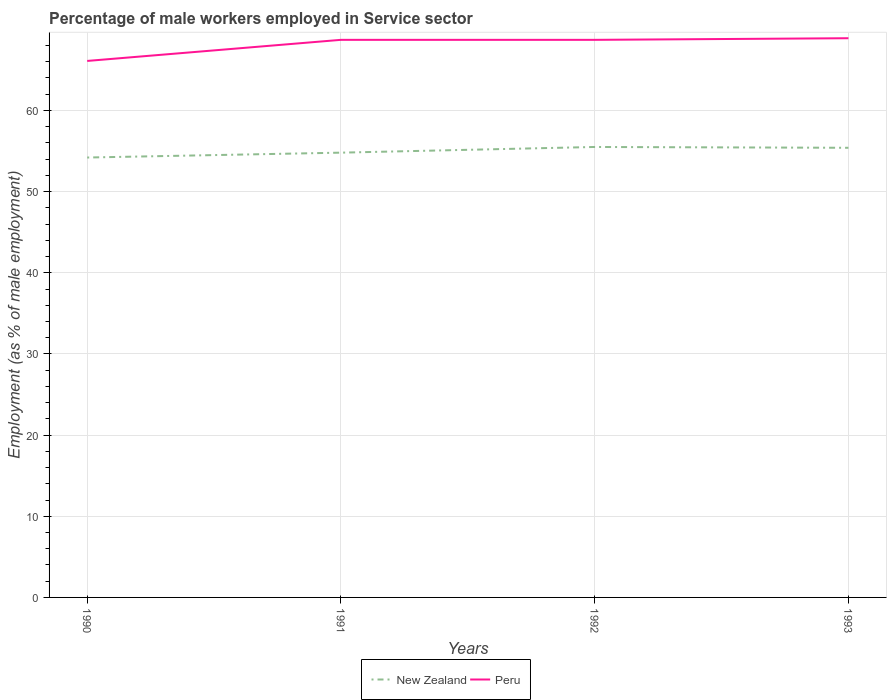Does the line corresponding to New Zealand intersect with the line corresponding to Peru?
Offer a terse response. No. Across all years, what is the maximum percentage of male workers employed in Service sector in New Zealand?
Make the answer very short. 54.2. In which year was the percentage of male workers employed in Service sector in Peru maximum?
Your response must be concise. 1990. What is the total percentage of male workers employed in Service sector in Peru in the graph?
Your response must be concise. -2.6. What is the difference between the highest and the second highest percentage of male workers employed in Service sector in Peru?
Ensure brevity in your answer.  2.8. What is the difference between the highest and the lowest percentage of male workers employed in Service sector in Peru?
Offer a terse response. 3. Is the percentage of male workers employed in Service sector in New Zealand strictly greater than the percentage of male workers employed in Service sector in Peru over the years?
Make the answer very short. Yes. What is the difference between two consecutive major ticks on the Y-axis?
Your answer should be compact. 10. Does the graph contain grids?
Keep it short and to the point. Yes. Where does the legend appear in the graph?
Your answer should be compact. Bottom center. How many legend labels are there?
Make the answer very short. 2. How are the legend labels stacked?
Your response must be concise. Horizontal. What is the title of the graph?
Provide a short and direct response. Percentage of male workers employed in Service sector. Does "Botswana" appear as one of the legend labels in the graph?
Offer a terse response. No. What is the label or title of the X-axis?
Offer a terse response. Years. What is the label or title of the Y-axis?
Provide a succinct answer. Employment (as % of male employment). What is the Employment (as % of male employment) of New Zealand in 1990?
Offer a terse response. 54.2. What is the Employment (as % of male employment) of Peru in 1990?
Provide a succinct answer. 66.1. What is the Employment (as % of male employment) in New Zealand in 1991?
Your response must be concise. 54.8. What is the Employment (as % of male employment) of Peru in 1991?
Offer a very short reply. 68.7. What is the Employment (as % of male employment) of New Zealand in 1992?
Keep it short and to the point. 55.5. What is the Employment (as % of male employment) of Peru in 1992?
Your response must be concise. 68.7. What is the Employment (as % of male employment) in New Zealand in 1993?
Your response must be concise. 55.4. What is the Employment (as % of male employment) in Peru in 1993?
Ensure brevity in your answer.  68.9. Across all years, what is the maximum Employment (as % of male employment) of New Zealand?
Provide a succinct answer. 55.5. Across all years, what is the maximum Employment (as % of male employment) in Peru?
Give a very brief answer. 68.9. Across all years, what is the minimum Employment (as % of male employment) in New Zealand?
Provide a short and direct response. 54.2. Across all years, what is the minimum Employment (as % of male employment) in Peru?
Your answer should be compact. 66.1. What is the total Employment (as % of male employment) of New Zealand in the graph?
Make the answer very short. 219.9. What is the total Employment (as % of male employment) of Peru in the graph?
Your response must be concise. 272.4. What is the difference between the Employment (as % of male employment) of New Zealand in 1990 and that in 1991?
Your answer should be compact. -0.6. What is the difference between the Employment (as % of male employment) in New Zealand in 1991 and that in 1992?
Your answer should be compact. -0.7. What is the difference between the Employment (as % of male employment) of Peru in 1991 and that in 1992?
Provide a succinct answer. 0. What is the difference between the Employment (as % of male employment) of New Zealand in 1991 and that in 1993?
Provide a succinct answer. -0.6. What is the difference between the Employment (as % of male employment) of Peru in 1991 and that in 1993?
Provide a short and direct response. -0.2. What is the difference between the Employment (as % of male employment) of New Zealand in 1990 and the Employment (as % of male employment) of Peru in 1991?
Offer a very short reply. -14.5. What is the difference between the Employment (as % of male employment) in New Zealand in 1990 and the Employment (as % of male employment) in Peru in 1992?
Provide a succinct answer. -14.5. What is the difference between the Employment (as % of male employment) of New Zealand in 1990 and the Employment (as % of male employment) of Peru in 1993?
Offer a terse response. -14.7. What is the difference between the Employment (as % of male employment) in New Zealand in 1991 and the Employment (as % of male employment) in Peru in 1992?
Make the answer very short. -13.9. What is the difference between the Employment (as % of male employment) in New Zealand in 1991 and the Employment (as % of male employment) in Peru in 1993?
Your response must be concise. -14.1. What is the average Employment (as % of male employment) in New Zealand per year?
Ensure brevity in your answer.  54.98. What is the average Employment (as % of male employment) in Peru per year?
Offer a very short reply. 68.1. In the year 1990, what is the difference between the Employment (as % of male employment) in New Zealand and Employment (as % of male employment) in Peru?
Ensure brevity in your answer.  -11.9. In the year 1992, what is the difference between the Employment (as % of male employment) in New Zealand and Employment (as % of male employment) in Peru?
Keep it short and to the point. -13.2. In the year 1993, what is the difference between the Employment (as % of male employment) of New Zealand and Employment (as % of male employment) of Peru?
Your response must be concise. -13.5. What is the ratio of the Employment (as % of male employment) in New Zealand in 1990 to that in 1991?
Provide a succinct answer. 0.99. What is the ratio of the Employment (as % of male employment) in Peru in 1990 to that in 1991?
Your response must be concise. 0.96. What is the ratio of the Employment (as % of male employment) in New Zealand in 1990 to that in 1992?
Make the answer very short. 0.98. What is the ratio of the Employment (as % of male employment) in Peru in 1990 to that in 1992?
Your response must be concise. 0.96. What is the ratio of the Employment (as % of male employment) in New Zealand in 1990 to that in 1993?
Offer a terse response. 0.98. What is the ratio of the Employment (as % of male employment) in Peru in 1990 to that in 1993?
Provide a short and direct response. 0.96. What is the ratio of the Employment (as % of male employment) of New Zealand in 1991 to that in 1992?
Offer a terse response. 0.99. What is the ratio of the Employment (as % of male employment) of New Zealand in 1991 to that in 1993?
Your answer should be compact. 0.99. What is the ratio of the Employment (as % of male employment) of Peru in 1991 to that in 1993?
Keep it short and to the point. 1. What is the difference between the highest and the second highest Employment (as % of male employment) in New Zealand?
Your answer should be very brief. 0.1. What is the difference between the highest and the second highest Employment (as % of male employment) in Peru?
Offer a very short reply. 0.2. What is the difference between the highest and the lowest Employment (as % of male employment) in New Zealand?
Keep it short and to the point. 1.3. 